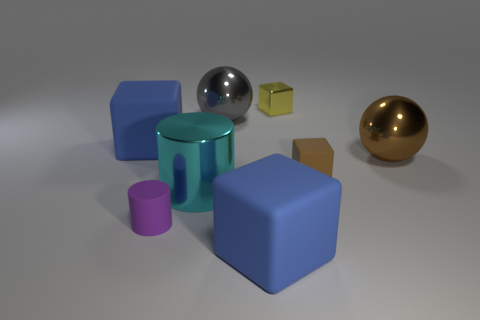What shape is the yellow shiny thing that is the same size as the brown matte cube?
Keep it short and to the point. Cube. What number of tiny matte blocks are the same color as the tiny shiny block?
Give a very brief answer. 0. What size is the blue cube that is to the right of the gray metallic sphere?
Offer a terse response. Large. How many purple matte things are the same size as the metal block?
Offer a terse response. 1. What is the color of the big cylinder that is the same material as the yellow block?
Give a very brief answer. Cyan. Is the number of large cyan objects to the right of the yellow cube less than the number of big cyan things?
Offer a very short reply. Yes. What shape is the yellow object that is made of the same material as the gray object?
Your response must be concise. Cube. How many shiny objects are cyan objects or tiny things?
Keep it short and to the point. 2. Are there an equal number of large gray metallic spheres on the right side of the small brown cube and large cyan balls?
Ensure brevity in your answer.  Yes. There is a matte block that is left of the metallic cylinder; is it the same color as the small metal cube?
Provide a succinct answer. No. 